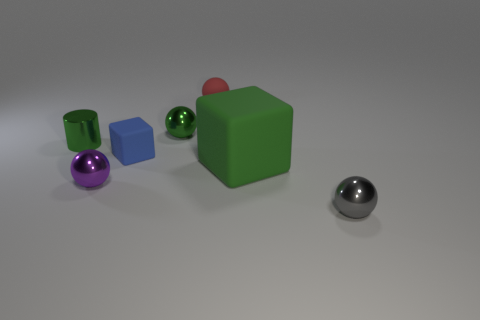Subtract all gray cylinders. Subtract all green cubes. How many cylinders are left? 1 Add 2 big yellow spheres. How many objects exist? 9 Subtract all balls. How many objects are left? 3 Add 1 small blue blocks. How many small blue blocks are left? 2 Add 1 large things. How many large things exist? 2 Subtract 0 blue cylinders. How many objects are left? 7 Subtract all large gray rubber blocks. Subtract all purple shiny objects. How many objects are left? 6 